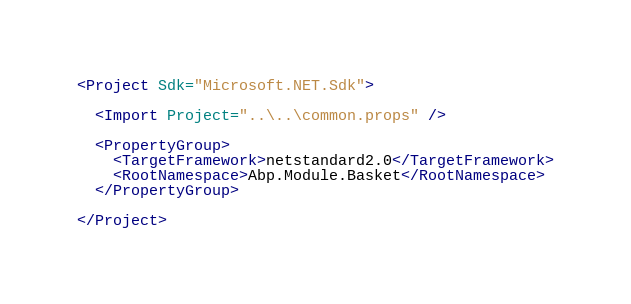<code> <loc_0><loc_0><loc_500><loc_500><_XML_><Project Sdk="Microsoft.NET.Sdk">

  <Import Project="..\..\common.props" />

  <PropertyGroup>
    <TargetFramework>netstandard2.0</TargetFramework>
    <RootNamespace>Abp.Module.Basket</RootNamespace>
  </PropertyGroup>

</Project>
</code> 